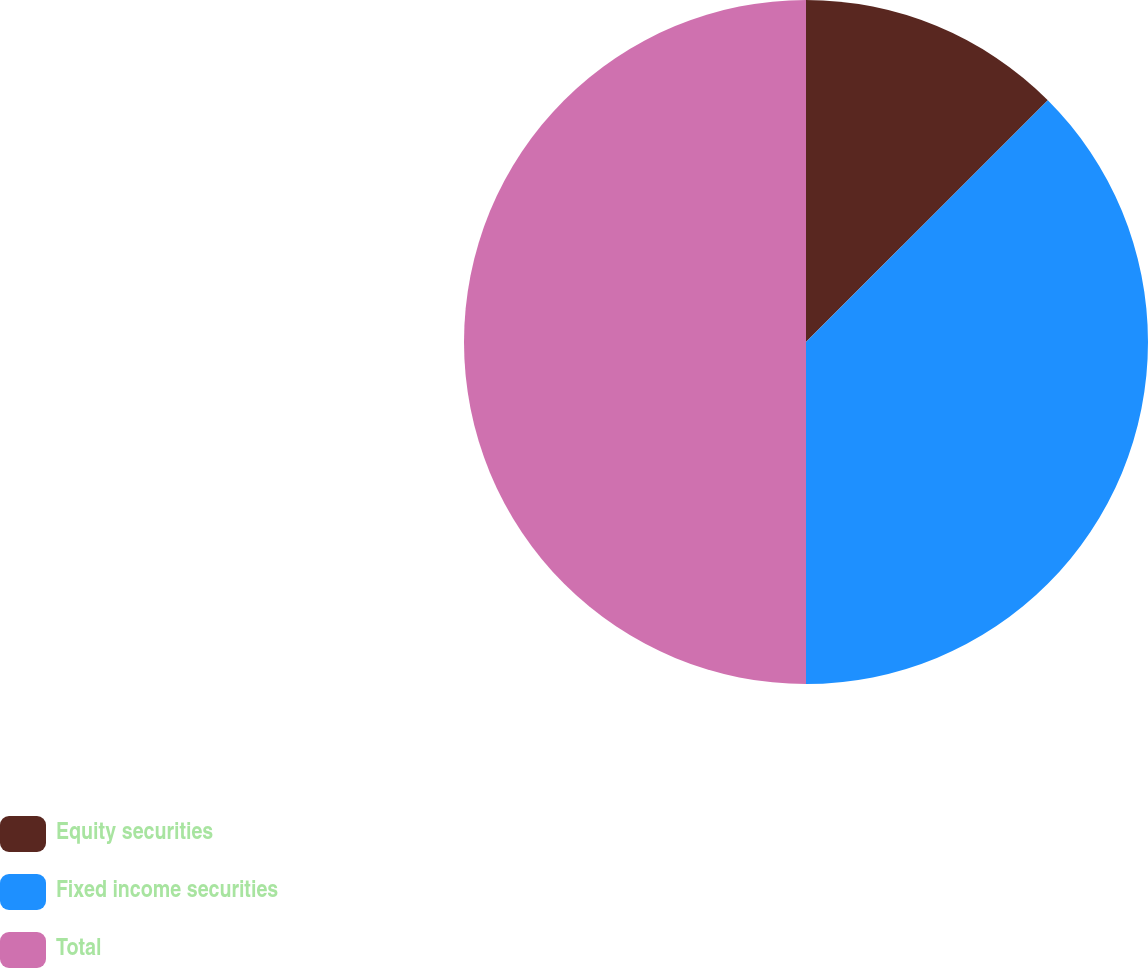Convert chart. <chart><loc_0><loc_0><loc_500><loc_500><pie_chart><fcel>Equity securities<fcel>Fixed income securities<fcel>Total<nl><fcel>12.5%<fcel>37.5%<fcel>50.0%<nl></chart> 